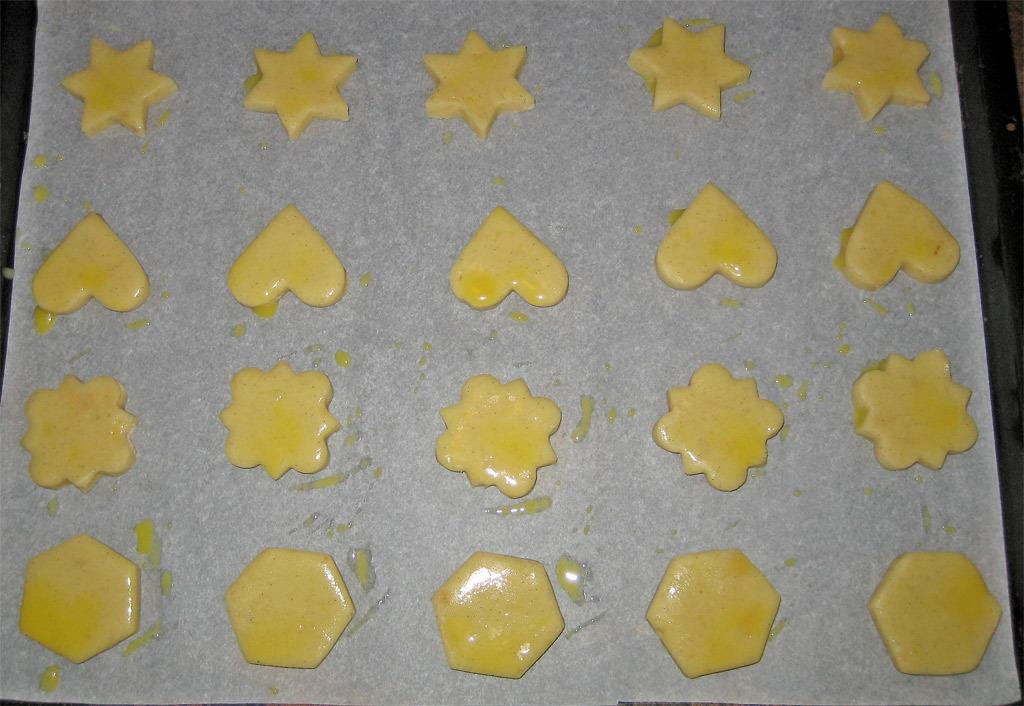What is present in the image related to food? There are food items in the image. How are the food items arranged or presented? The food items are in different shapes. What is the food items placed on? The food items are on a paper. What is the paper resting on? The paper is on a black object. Can you see the person's teeth smiling in the image? There is no person or teeth visible in the image; it only features food items on a paper. 